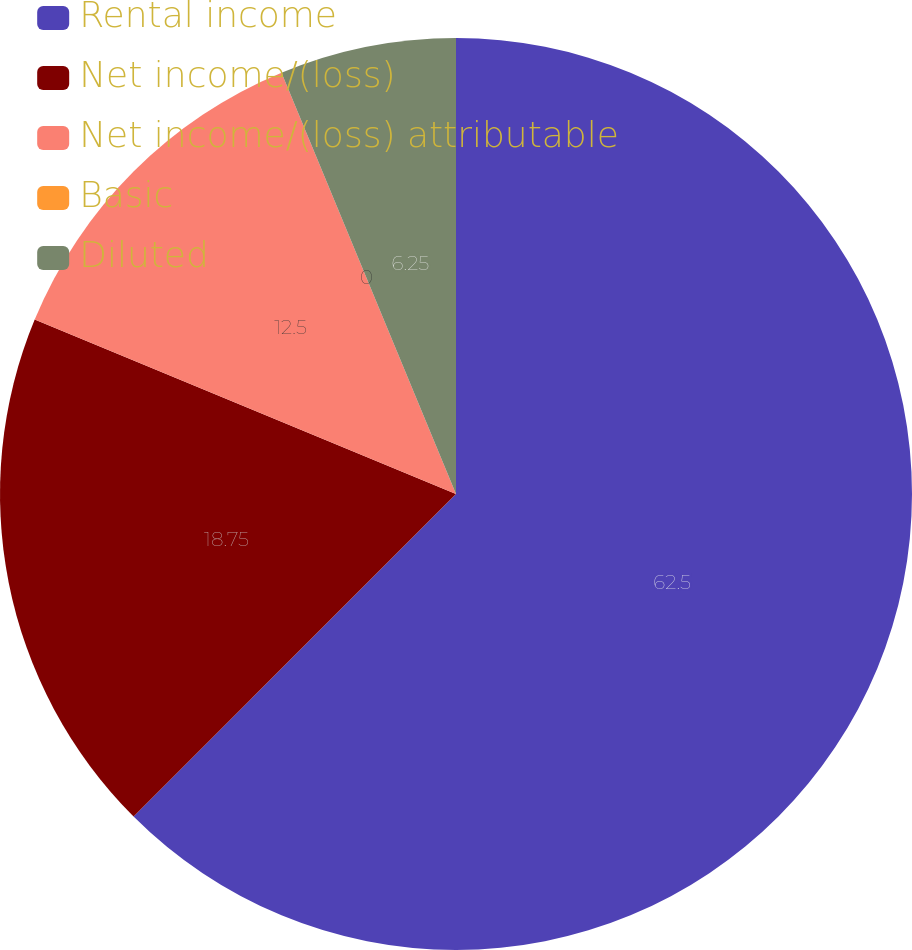<chart> <loc_0><loc_0><loc_500><loc_500><pie_chart><fcel>Rental income<fcel>Net income/(loss)<fcel>Net income/(loss) attributable<fcel>Basic<fcel>Diluted<nl><fcel>62.5%<fcel>18.75%<fcel>12.5%<fcel>0.0%<fcel>6.25%<nl></chart> 